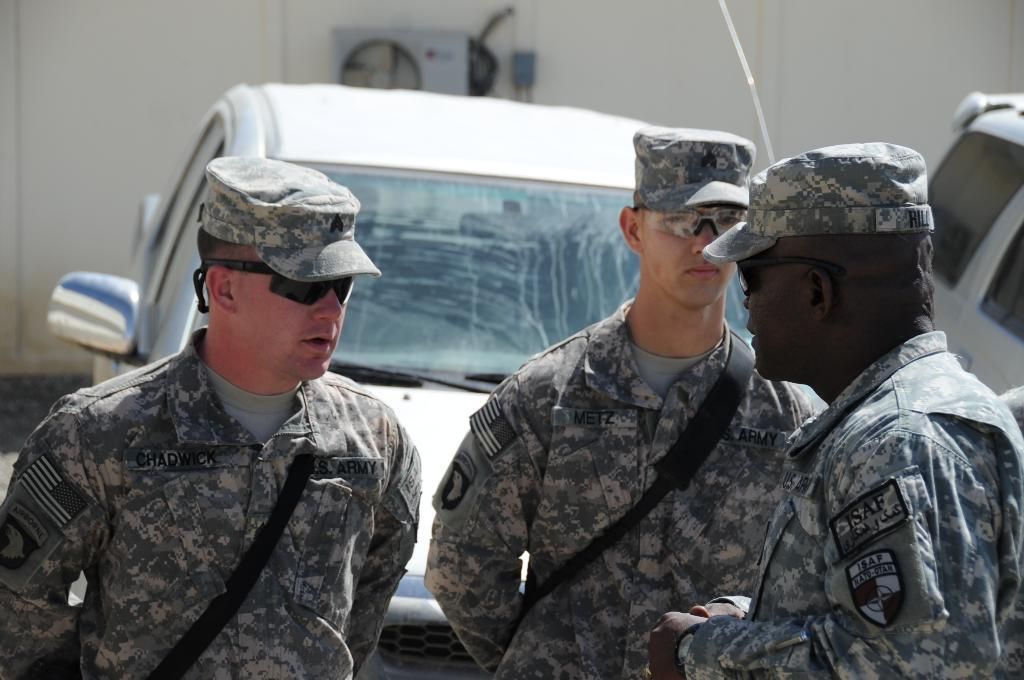What type of eyewear are the people in the image wearing? The people in the image are wearing spectacles. What type of headwear are the people wearing? The people are wearing caps. What position are the people in the image? The people are standing. What type of transportation can be seen in the image? There are vehicles in the image. What is on the wall in the image? There is an object on the wall in the image. What can be seen under the people's feet in the image? The ground is visible in the image. Can you see any waves in the image? There are no waves visible in the image. Is there a plane flying in the image? There is no plane present in the image. 